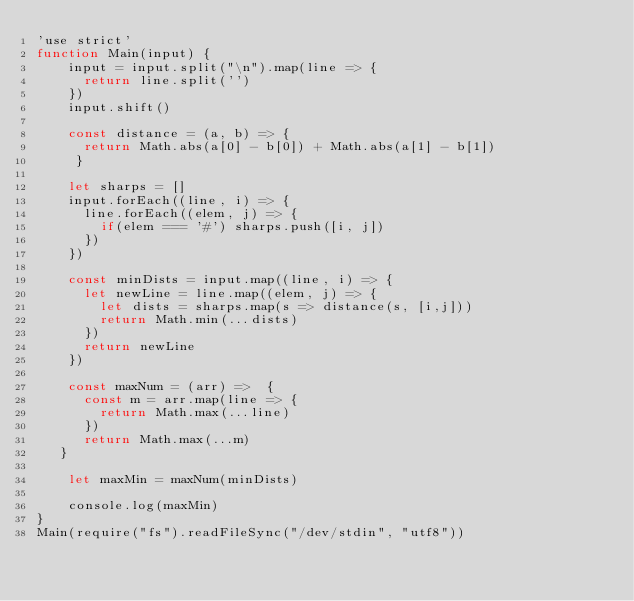Convert code to text. <code><loc_0><loc_0><loc_500><loc_500><_JavaScript_>'use strict'
function Main(input) {
    input = input.split("\n").map(line => {
      return line.split('')
    })
    input.shift()

    const distance = (a, b) => {
      return Math.abs(a[0] - b[0]) + Math.abs(a[1] - b[1]) 
     } 

    let sharps = []
    input.forEach((line, i) => {
      line.forEach((elem, j) => {
        if(elem === '#') sharps.push([i, j]) 
      })
    })

    const minDists = input.map((line, i) => {
      let newLine = line.map((elem, j) => {
        let dists = sharps.map(s => distance(s, [i,j]))
        return Math.min(...dists)
      }) 
      return newLine
    })

    const maxNum = (arr) =>  {
      const m = arr.map(line => {
        return Math.max(...line)
      })
      return Math.max(...m) 
   }  

    let maxMin = maxNum(minDists)

    console.log(maxMin)
}
Main(require("fs").readFileSync("/dev/stdin", "utf8"))</code> 